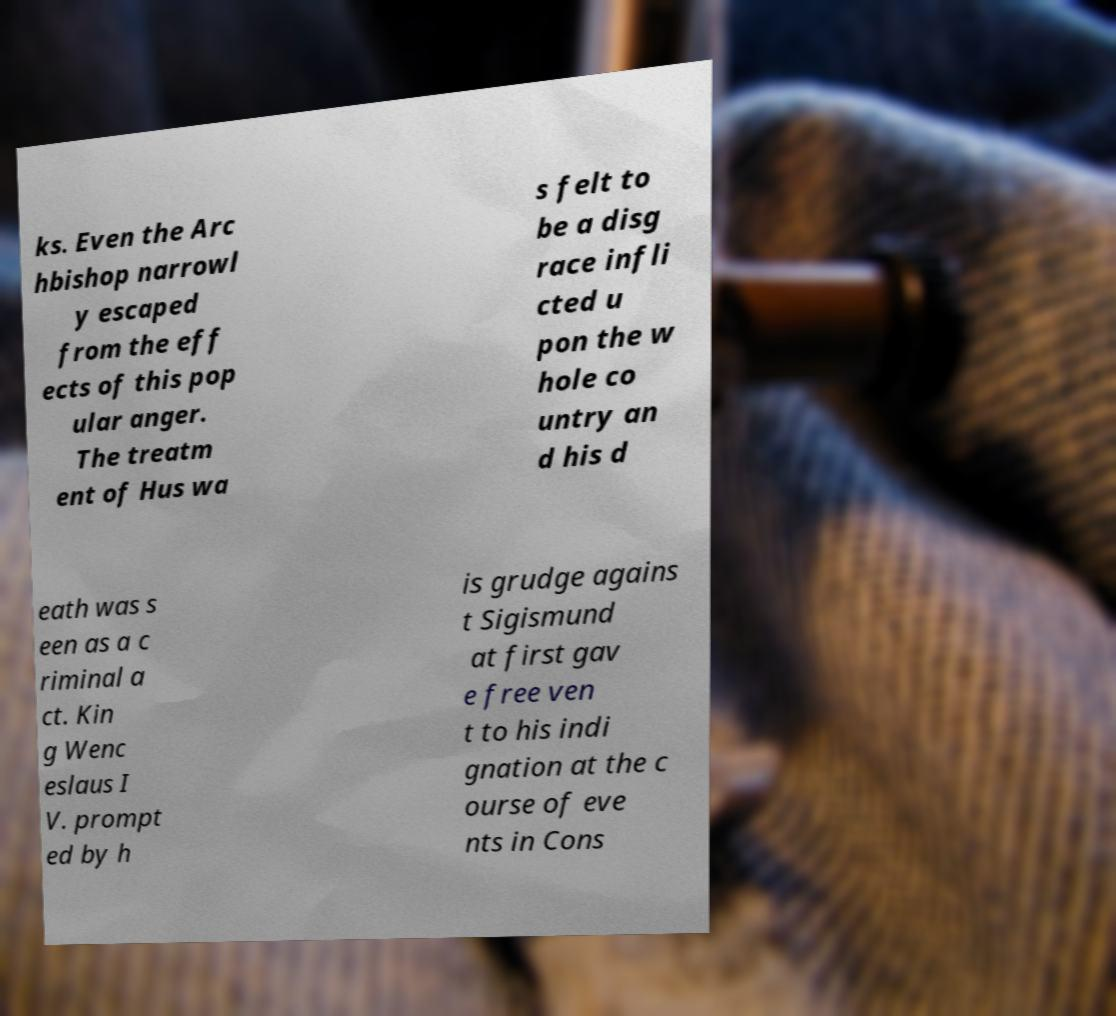Could you assist in decoding the text presented in this image and type it out clearly? ks. Even the Arc hbishop narrowl y escaped from the eff ects of this pop ular anger. The treatm ent of Hus wa s felt to be a disg race infli cted u pon the w hole co untry an d his d eath was s een as a c riminal a ct. Kin g Wenc eslaus I V. prompt ed by h is grudge agains t Sigismund at first gav e free ven t to his indi gnation at the c ourse of eve nts in Cons 